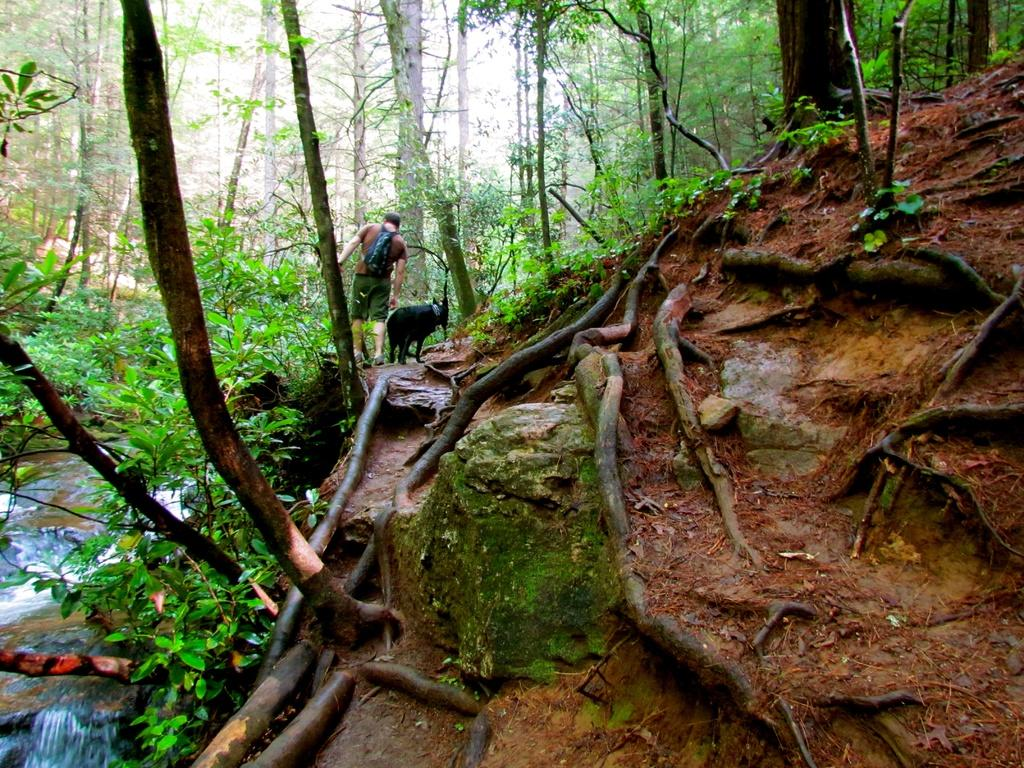What can be seen at the right side of the image? There are roots of a tree at the right side of the image. What is present at the left side of the image? There is water at the left side of the image. What type of natural elements are visible in the image? There are trees in the image. Can you describe the man in the image? The man is wearing a backpack, t-shirt, and shorts. What else is present in the image besides the man and trees? There is an animal in the image. What word is written on the tree trunk in the image? There are no words written on the tree trunk in the image. What type of flowers can be seen growing near the water in the image? There are no flowers present in the image. 